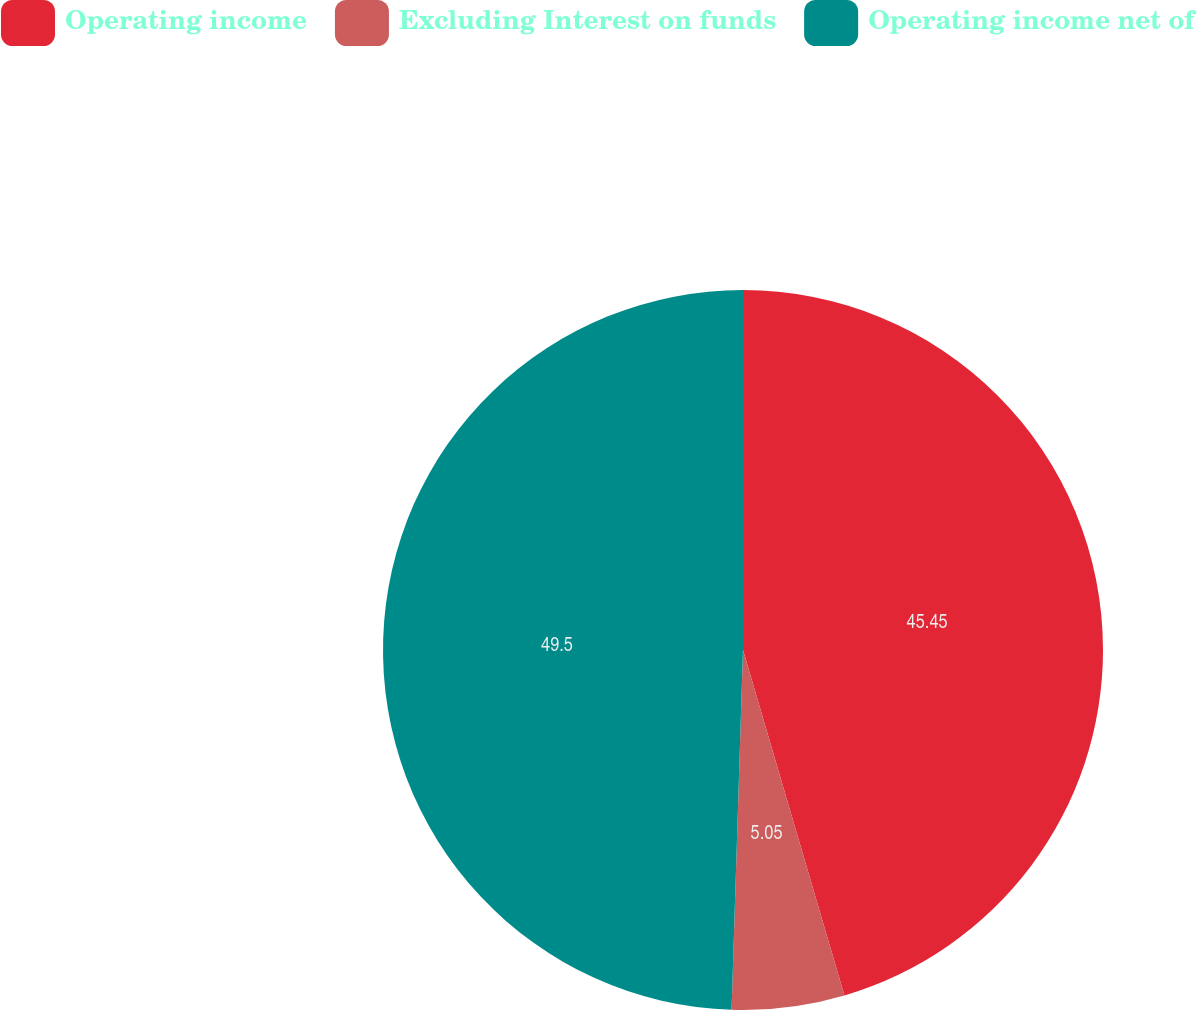Convert chart. <chart><loc_0><loc_0><loc_500><loc_500><pie_chart><fcel>Operating income<fcel>Excluding Interest on funds<fcel>Operating income net of<nl><fcel>45.45%<fcel>5.05%<fcel>49.49%<nl></chart> 